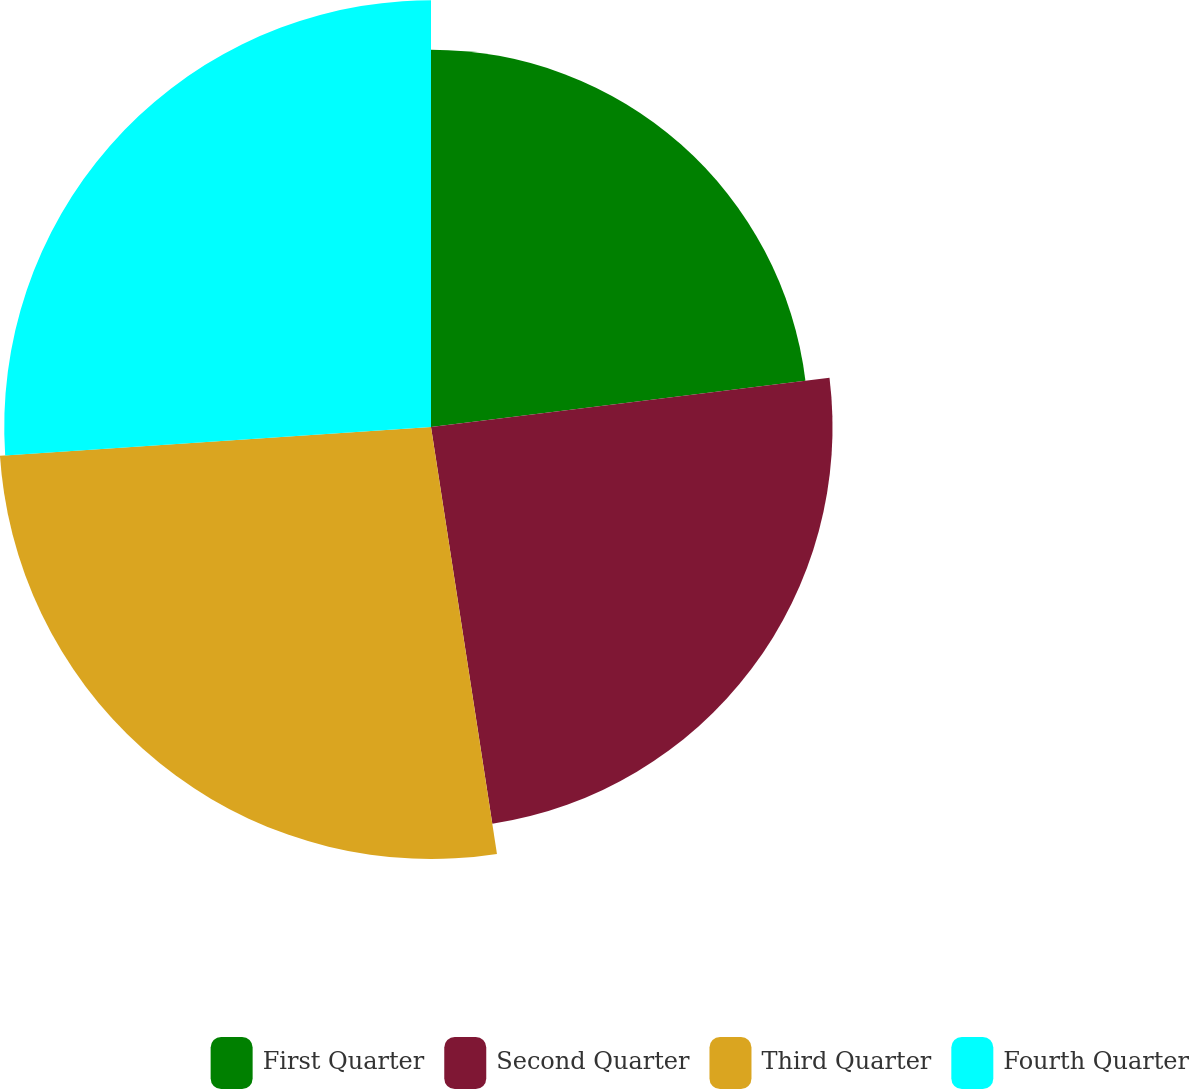<chart> <loc_0><loc_0><loc_500><loc_500><pie_chart><fcel>First Quarter<fcel>Second Quarter<fcel>Third Quarter<fcel>Fourth Quarter<nl><fcel>23.04%<fcel>24.52%<fcel>26.38%<fcel>26.06%<nl></chart> 